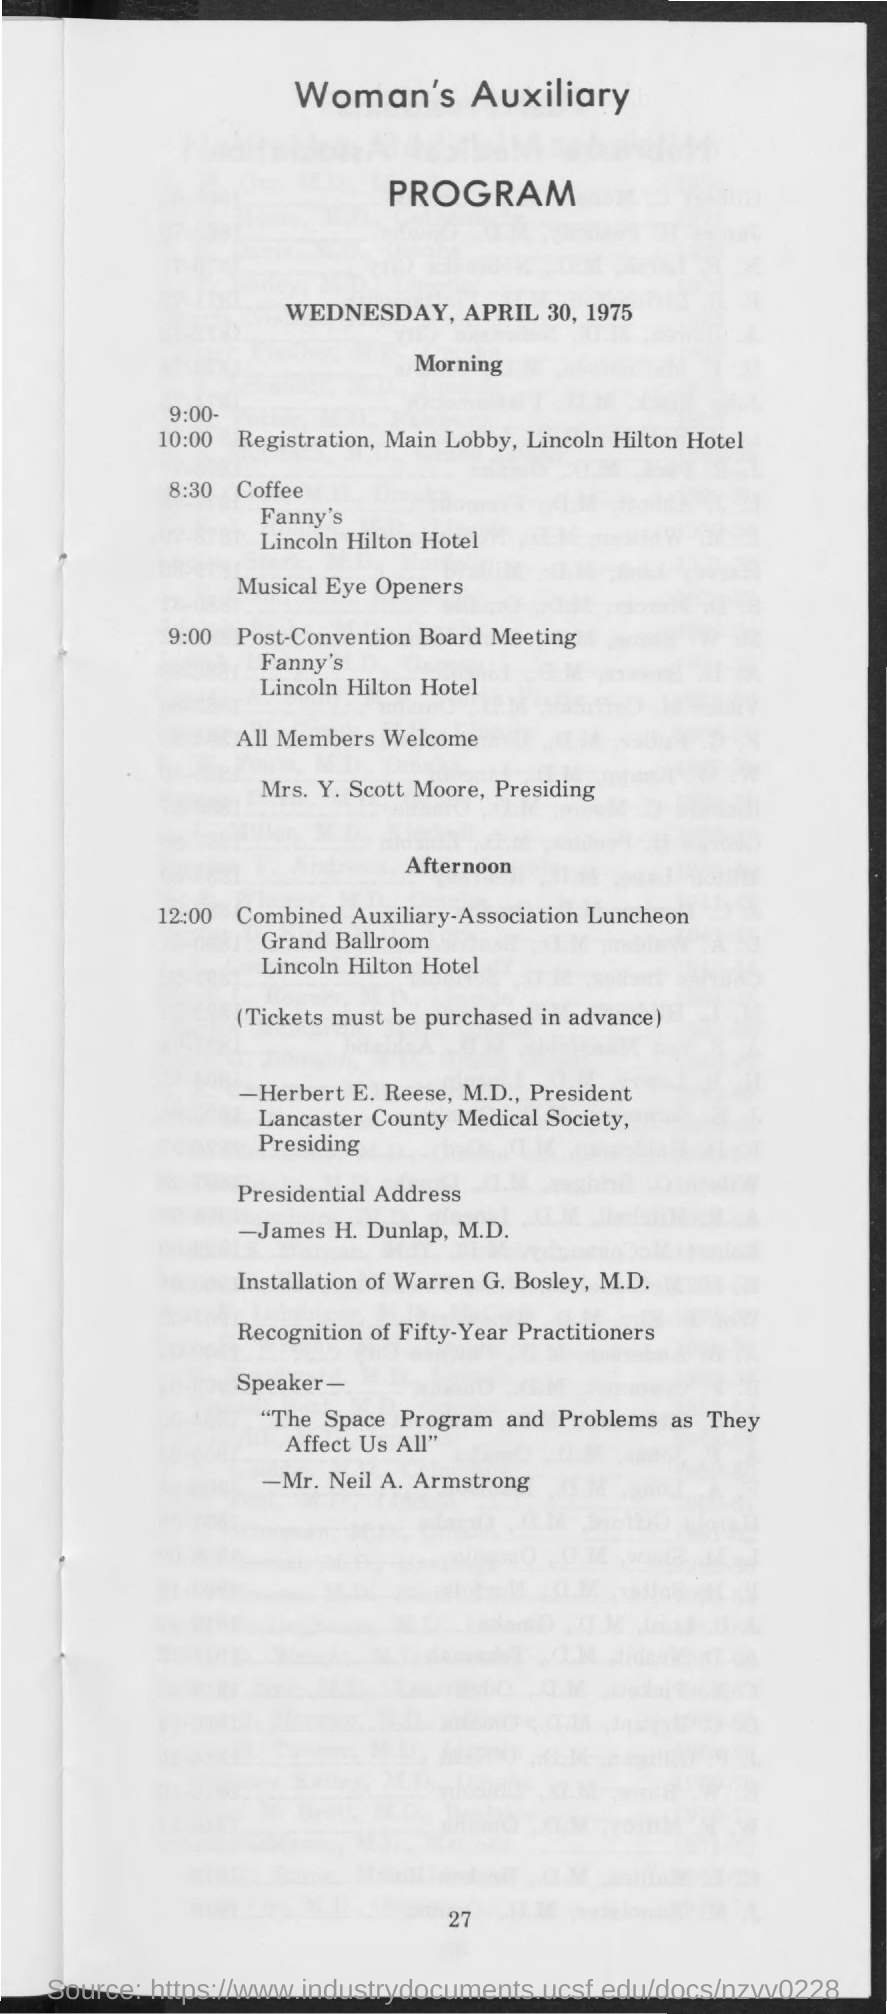List a handful of essential elements in this visual. The document indicates that the date is Wednesday, April 30, 1975. 